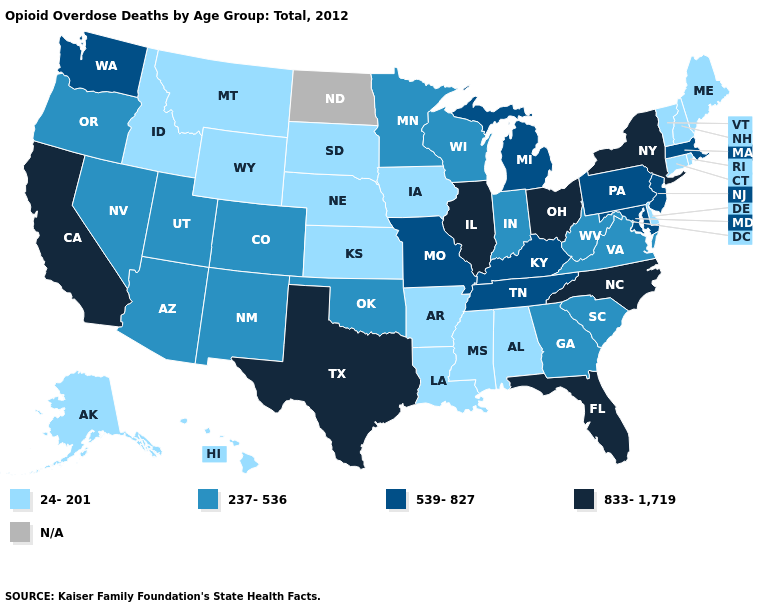Name the states that have a value in the range 24-201?
Answer briefly. Alabama, Alaska, Arkansas, Connecticut, Delaware, Hawaii, Idaho, Iowa, Kansas, Louisiana, Maine, Mississippi, Montana, Nebraska, New Hampshire, Rhode Island, South Dakota, Vermont, Wyoming. Name the states that have a value in the range 833-1,719?
Answer briefly. California, Florida, Illinois, New York, North Carolina, Ohio, Texas. Name the states that have a value in the range N/A?
Be succinct. North Dakota. What is the lowest value in the Northeast?
Keep it brief. 24-201. Does the map have missing data?
Be succinct. Yes. Which states have the lowest value in the USA?
Give a very brief answer. Alabama, Alaska, Arkansas, Connecticut, Delaware, Hawaii, Idaho, Iowa, Kansas, Louisiana, Maine, Mississippi, Montana, Nebraska, New Hampshire, Rhode Island, South Dakota, Vermont, Wyoming. Name the states that have a value in the range 24-201?
Short answer required. Alabama, Alaska, Arkansas, Connecticut, Delaware, Hawaii, Idaho, Iowa, Kansas, Louisiana, Maine, Mississippi, Montana, Nebraska, New Hampshire, Rhode Island, South Dakota, Vermont, Wyoming. What is the highest value in the MidWest ?
Concise answer only. 833-1,719. What is the lowest value in the West?
Keep it brief. 24-201. What is the highest value in the USA?
Give a very brief answer. 833-1,719. Name the states that have a value in the range 237-536?
Short answer required. Arizona, Colorado, Georgia, Indiana, Minnesota, Nevada, New Mexico, Oklahoma, Oregon, South Carolina, Utah, Virginia, West Virginia, Wisconsin. Does Maine have the highest value in the USA?
Keep it brief. No. Name the states that have a value in the range 237-536?
Answer briefly. Arizona, Colorado, Georgia, Indiana, Minnesota, Nevada, New Mexico, Oklahoma, Oregon, South Carolina, Utah, Virginia, West Virginia, Wisconsin. What is the value of Wyoming?
Keep it brief. 24-201. Does the first symbol in the legend represent the smallest category?
Concise answer only. Yes. 